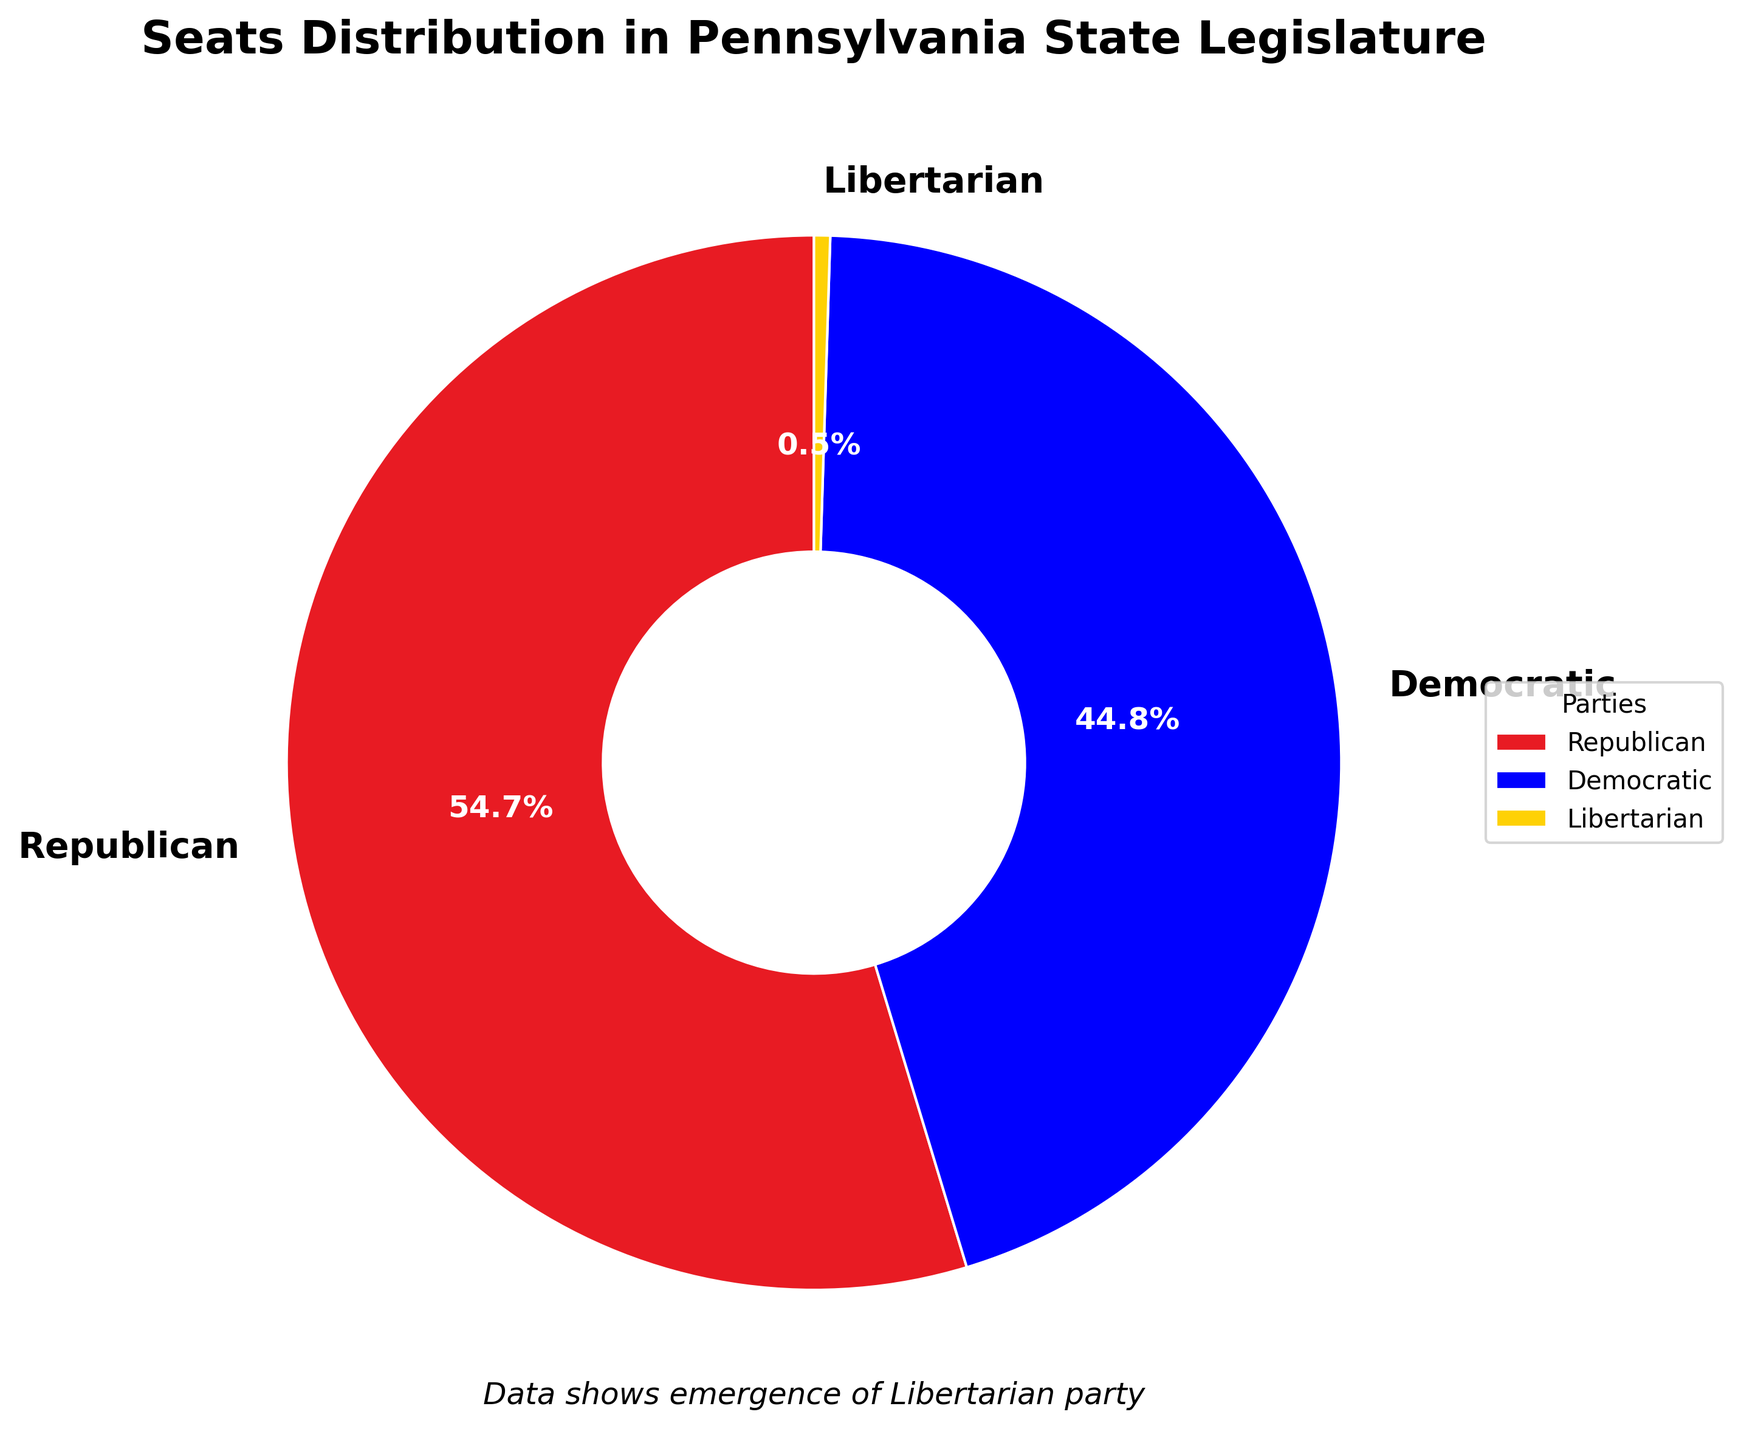What percentage of seats do the Republican and Democratic parties together hold? First, find the percentage of seats held by each party. The Republicans hold 111 seats, and the Democrats hold 91 seats. Together, they hold 111 + 91 = 202 seats. The total number of seats is 111 (Republican) + 91 (Democratic) + 1 (Libertarian) = 203. So, (202/203) * 100 ≈ 99.5%.
Answer: 99.5% What percentage of seats does the Libertarian party hold? The Libertarians hold 1 seat out of a total of 203 seats. To find the percentage, (1/203) * 100 ≈ 0.5%.
Answer: 0.5% Which party holds the majority of seats? The party with the majority has more than half of the total seats. The total number of seats is 203, so the majority is more than 203/2 = 101.5 seats. The Republicans hold 111 seats, which is more than 101.5.
Answer: Republican What is the difference in the number of seats held by the Republican and Democratic parties? The Republicans hold 111 seats, and the Democrats hold 91 seats. The difference is 111 - 91 = 20 seats.
Answer: 20 seats How many times more seats do the Republicans hold compared to the Libertarians? The Republicans hold 111 seats, and the Libertarians hold 1 seat. The ratio of Republican to Libertarian seats is 111/1 = 111 times.
Answer: 111 times What fraction of the seats does the Democratic party hold? The Democrats hold 91 seats out of a total of 203 seats. The fraction is 91/203.
Answer: 91/203 Are there any parties with 0 seats? According to the data, the Green, Constitution, and Independent parties each hold 0 seats.
Answer: Yes What is the combined seat percentage of all minor parties (non-Republican and non-Democratic parties)? The only minor party with seats is the Libertarian party with 1 seat. The total number of seats is 203. So, (1/203) * 100 ≈ 0.5%.
Answer: 0.5% Do the Republican and Democratic parties have an equal number of seats? No, the Republicans have 111 seats, while the Democrats have 91 seats.
Answer: No What is the visual representation color of the Libertarian party in the chart? The Libertarian party is represented by the color yellow in the pie chart.
Answer: Yellow 